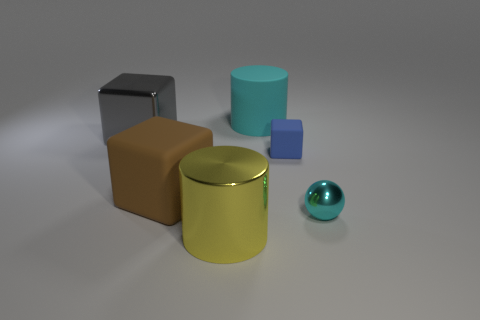Subtract all matte cubes. How many cubes are left? 1 Subtract all brown blocks. How many blocks are left? 2 Subtract all balls. How many objects are left? 5 Add 1 yellow metal cylinders. How many objects exist? 7 Subtract all red balls. How many blue cubes are left? 1 Subtract all cyan rubber things. Subtract all large brown matte things. How many objects are left? 4 Add 4 tiny blue objects. How many tiny blue objects are left? 5 Add 2 tiny brown shiny spheres. How many tiny brown shiny spheres exist? 2 Subtract 1 yellow cylinders. How many objects are left? 5 Subtract 1 cylinders. How many cylinders are left? 1 